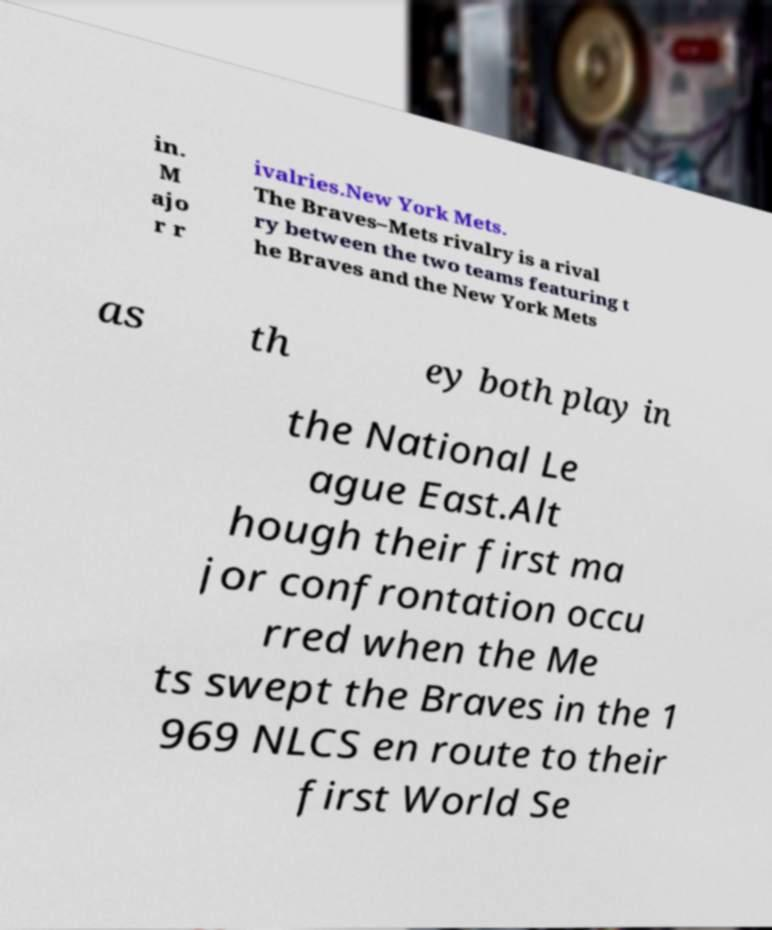For documentation purposes, I need the text within this image transcribed. Could you provide that? in. M ajo r r ivalries.New York Mets. The Braves–Mets rivalry is a rival ry between the two teams featuring t he Braves and the New York Mets as th ey both play in the National Le ague East.Alt hough their first ma jor confrontation occu rred when the Me ts swept the Braves in the 1 969 NLCS en route to their first World Se 